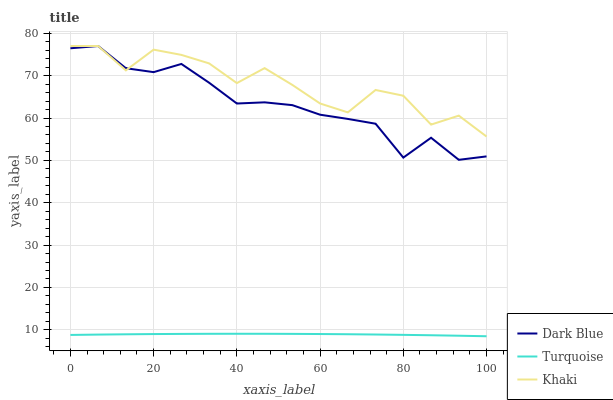Does Turquoise have the minimum area under the curve?
Answer yes or no. Yes. Does Khaki have the maximum area under the curve?
Answer yes or no. Yes. Does Khaki have the minimum area under the curve?
Answer yes or no. No. Does Turquoise have the maximum area under the curve?
Answer yes or no. No. Is Turquoise the smoothest?
Answer yes or no. Yes. Is Khaki the roughest?
Answer yes or no. Yes. Is Khaki the smoothest?
Answer yes or no. No. Is Turquoise the roughest?
Answer yes or no. No. Does Khaki have the lowest value?
Answer yes or no. No. Does Khaki have the highest value?
Answer yes or no. Yes. Does Turquoise have the highest value?
Answer yes or no. No. Is Turquoise less than Khaki?
Answer yes or no. Yes. Is Khaki greater than Turquoise?
Answer yes or no. Yes. Does Turquoise intersect Khaki?
Answer yes or no. No. 